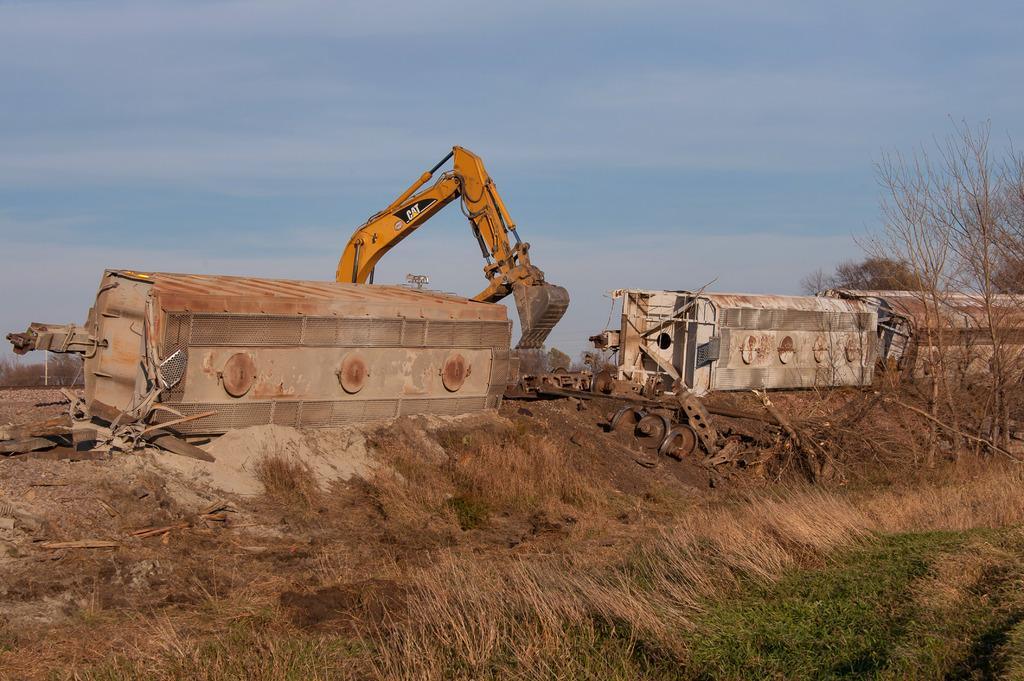How would you summarize this image in a sentence or two? In this image there are train wagons which are fallen on the ground one after the other. There is a crane in between them. At the top there is the sky. At the bottom there is grass. On the right side there are dry sticks. On the ground there are metal rods. 